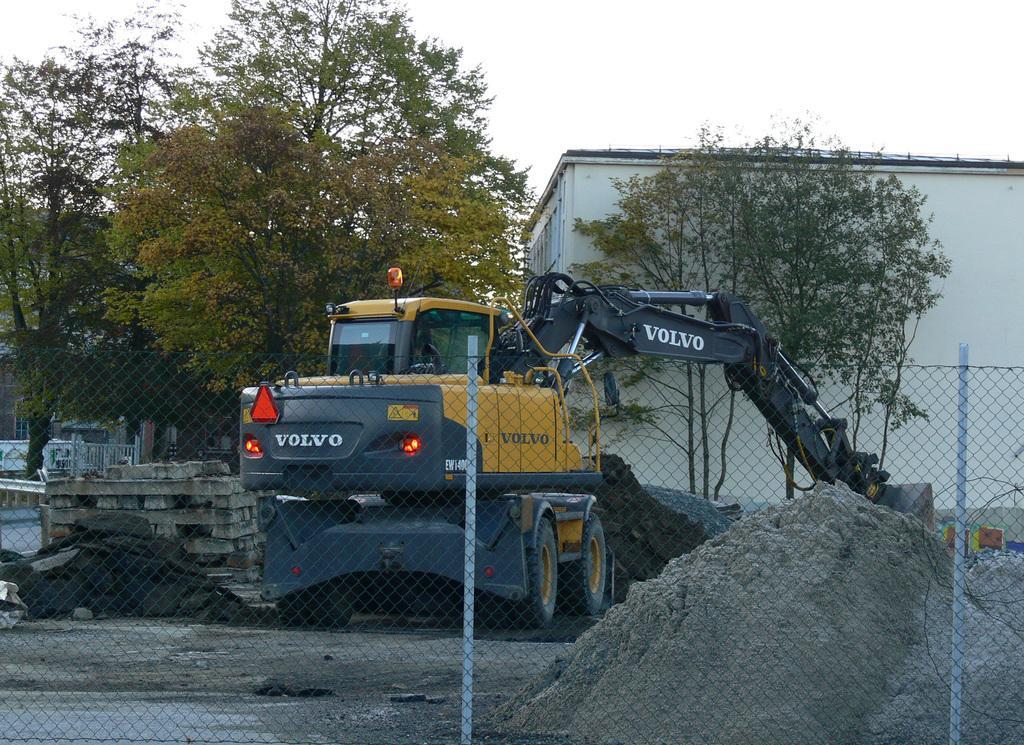In one or two sentences, can you explain what this image depicts? In this image, we can see a building and some trees. There is an excavator in the middle of the image. There are wooden pallets on the left side of the image. There is a mesh fencing at the bottom of the image. There is a sky at the top of the image. 